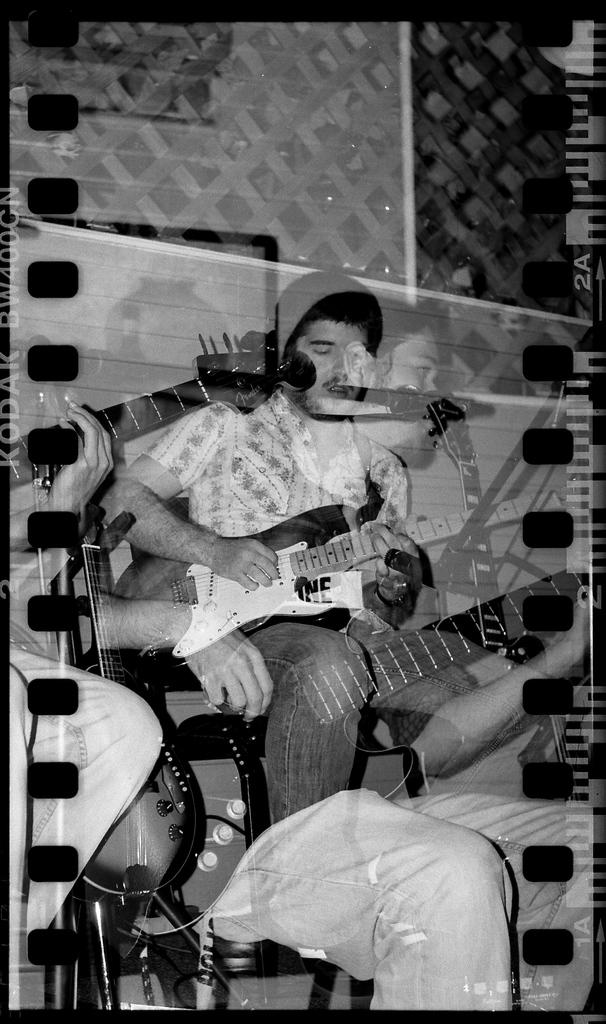What is the man in the image doing? The man is playing the guitar in the image. Can you describe the man's activity in more detail? The man is playing the guitar, which suggests he might be a musician or performing for an audience. Has the image been altered in any way? Yes, the image has been edited. What type of feather can be seen on the guitar in the image? There is no feather present on the guitar in the image. What adjustment can be made to the guitar in the image? The image has been edited, but there is no specific adjustment to the guitar mentioned in the provided facts. 